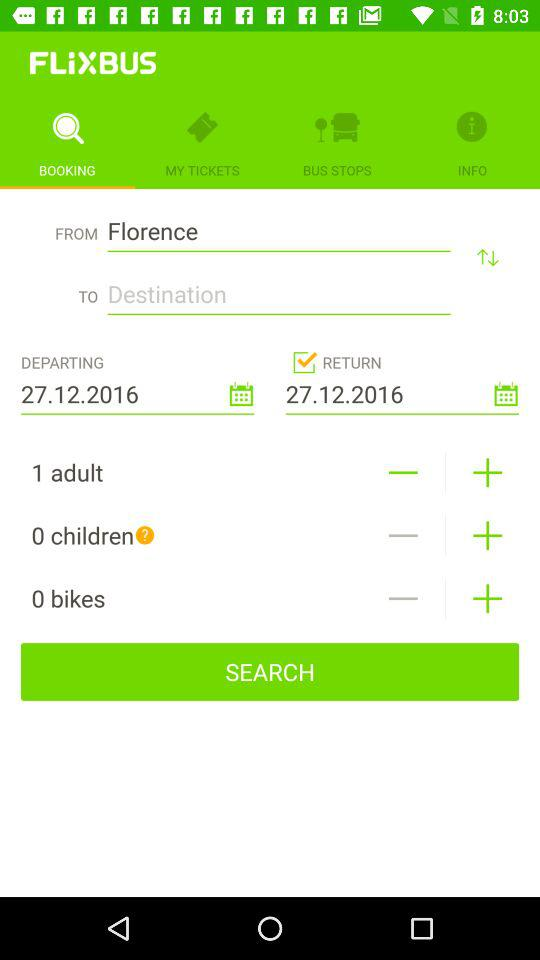What is the departing date? The departing date is December 27, 2016. 